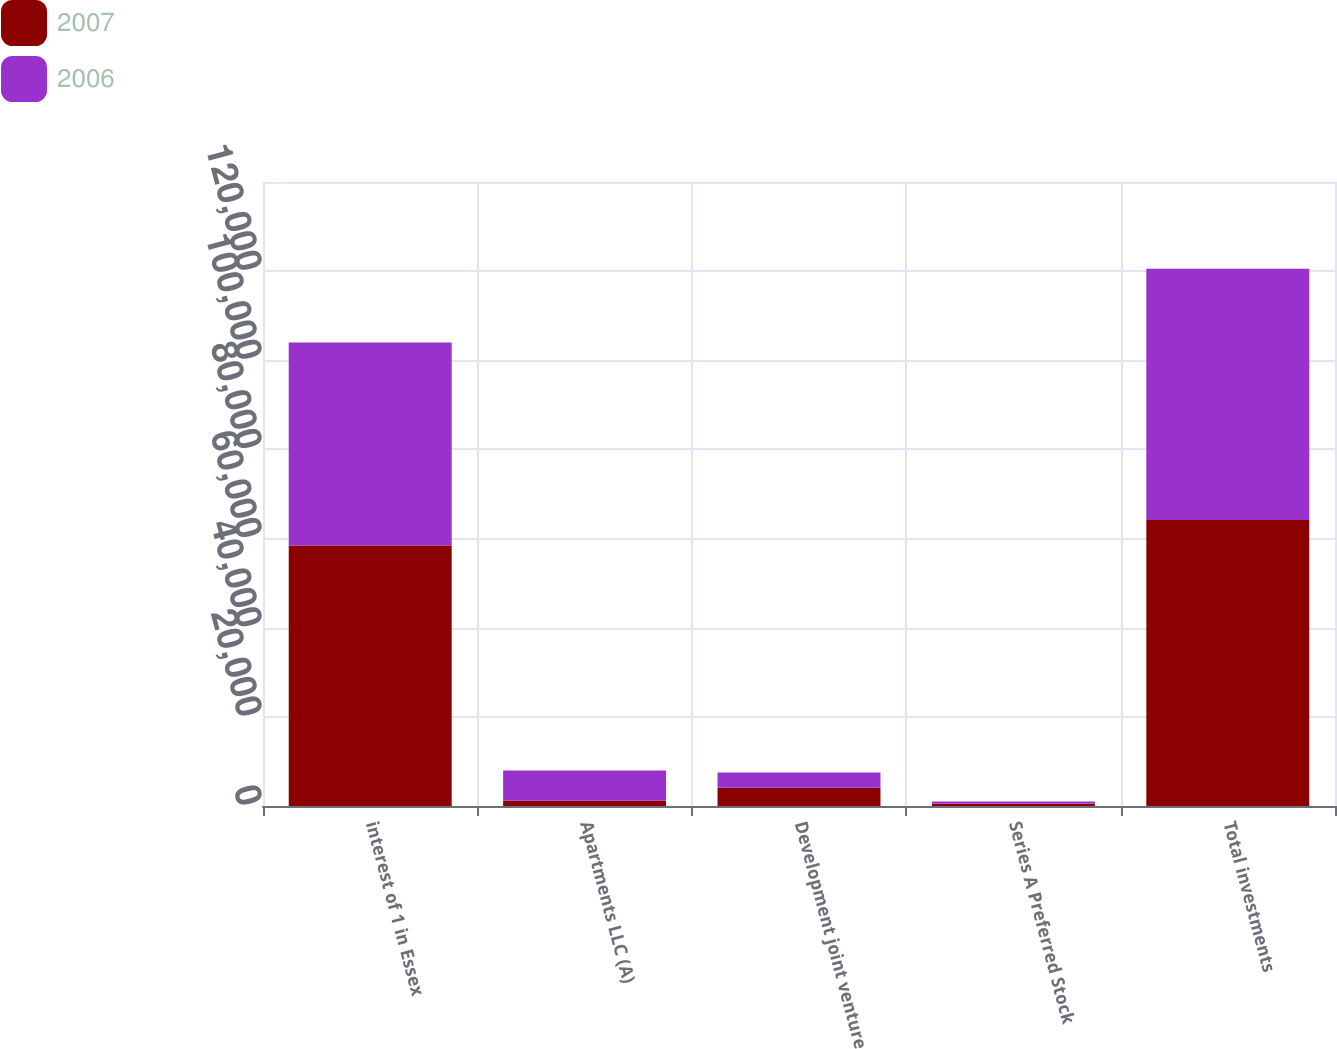Convert chart. <chart><loc_0><loc_0><loc_500><loc_500><stacked_bar_chart><ecel><fcel>interest of 1 in Essex<fcel>Apartments LLC (A)<fcel>Development joint venture<fcel>Series A Preferred Stock<fcel>Total investments<nl><fcel>2007<fcel>58419<fcel>1182<fcel>4090<fcel>500<fcel>64191<nl><fcel>2006<fcel>45598<fcel>6806<fcel>3414<fcel>500<fcel>56318<nl></chart> 